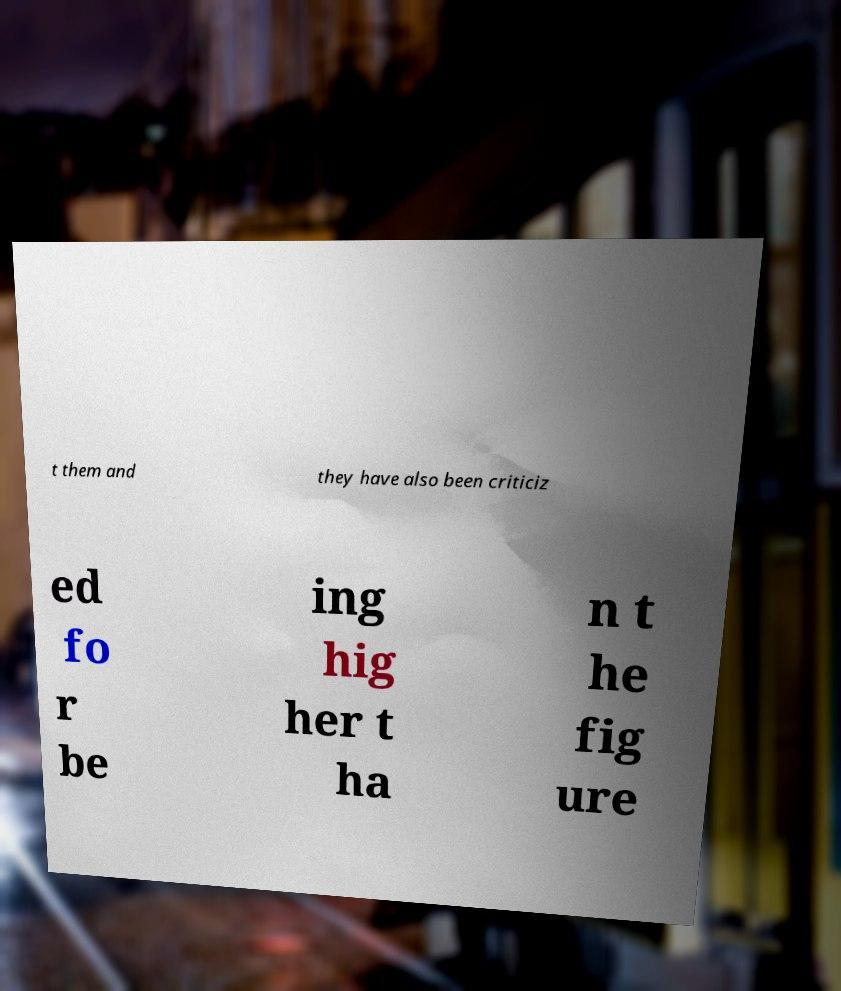Please read and relay the text visible in this image. What does it say? t them and they have also been criticiz ed fo r be ing hig her t ha n t he fig ure 